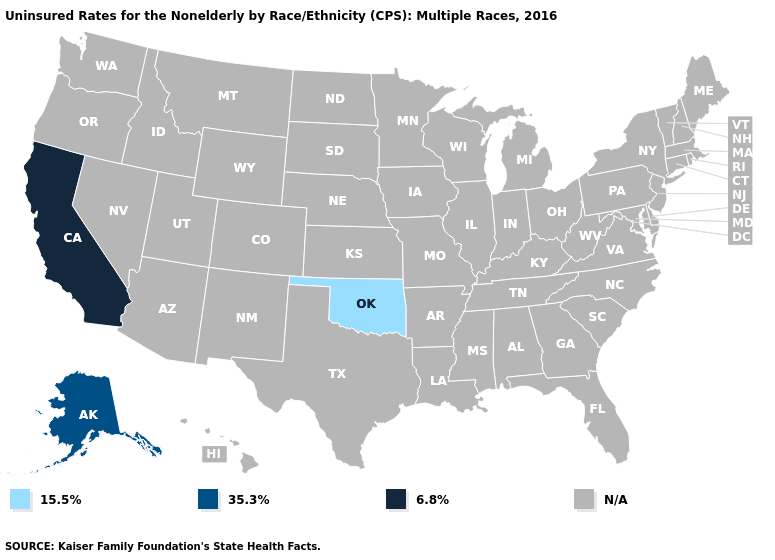Name the states that have a value in the range 35.3%?
Quick response, please. Alaska. Does California have the highest value in the USA?
Give a very brief answer. Yes. Does Alaska have the lowest value in the West?
Answer briefly. Yes. How many symbols are there in the legend?
Quick response, please. 4. Does the first symbol in the legend represent the smallest category?
Answer briefly. Yes. Name the states that have a value in the range 6.8%?
Give a very brief answer. California. Which states have the lowest value in the USA?
Keep it brief. Oklahoma. Name the states that have a value in the range 15.5%?
Be succinct. Oklahoma. Does Oklahoma have the highest value in the USA?
Quick response, please. No. What is the lowest value in the USA?
Answer briefly. 15.5%. What is the value of Georgia?
Keep it brief. N/A. How many symbols are there in the legend?
Short answer required. 4. 